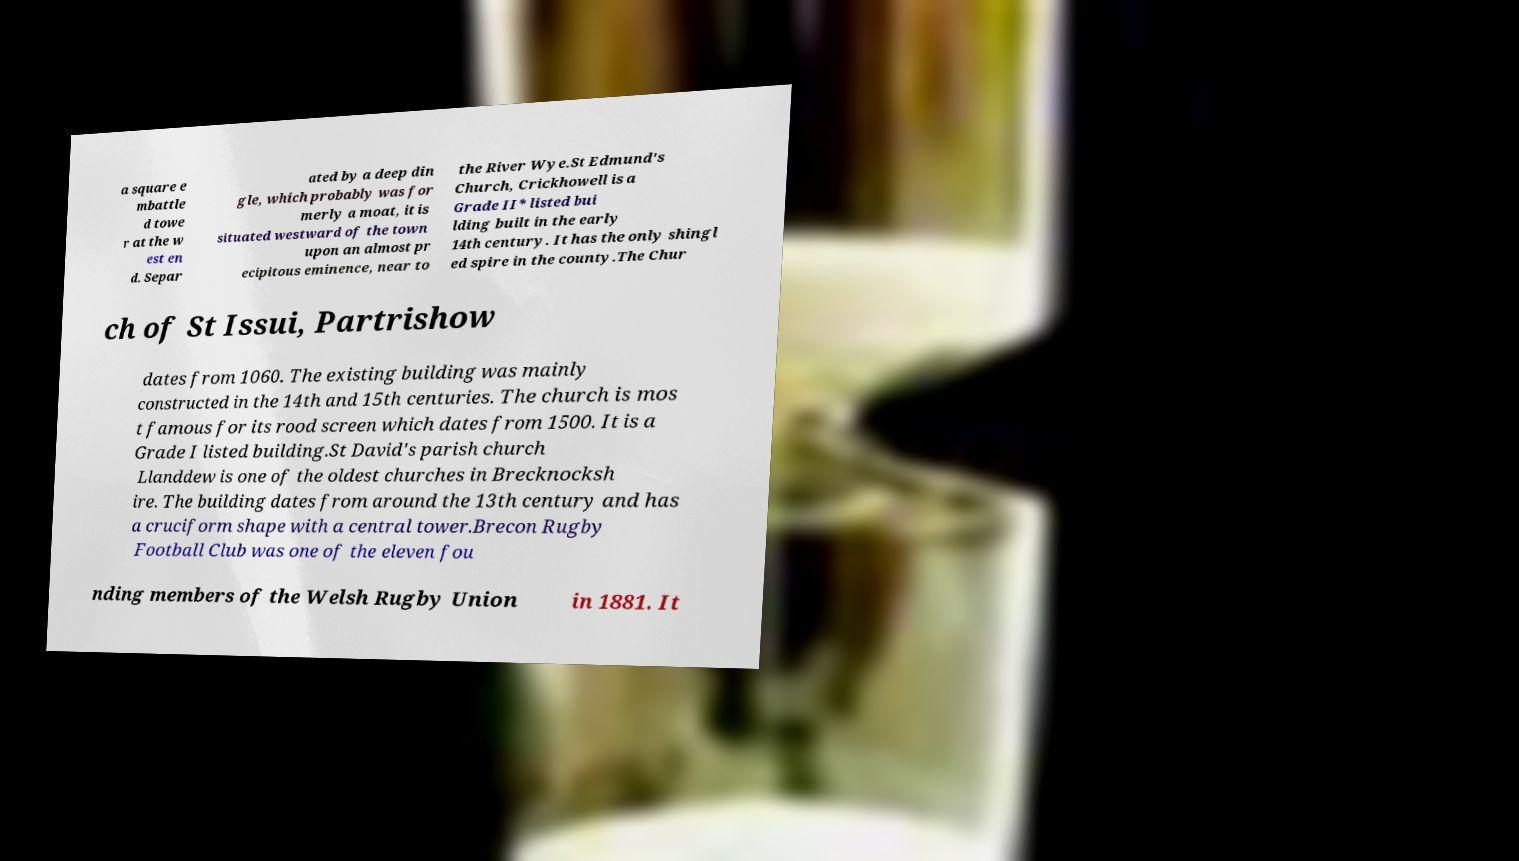Please read and relay the text visible in this image. What does it say? a square e mbattle d towe r at the w est en d. Separ ated by a deep din gle, which probably was for merly a moat, it is situated westward of the town upon an almost pr ecipitous eminence, near to the River Wye.St Edmund's Church, Crickhowell is a Grade II* listed bui lding built in the early 14th century. It has the only shingl ed spire in the county.The Chur ch of St Issui, Partrishow dates from 1060. The existing building was mainly constructed in the 14th and 15th centuries. The church is mos t famous for its rood screen which dates from 1500. It is a Grade I listed building.St David's parish church Llanddew is one of the oldest churches in Brecknocksh ire. The building dates from around the 13th century and has a cruciform shape with a central tower.Brecon Rugby Football Club was one of the eleven fou nding members of the Welsh Rugby Union in 1881. It 